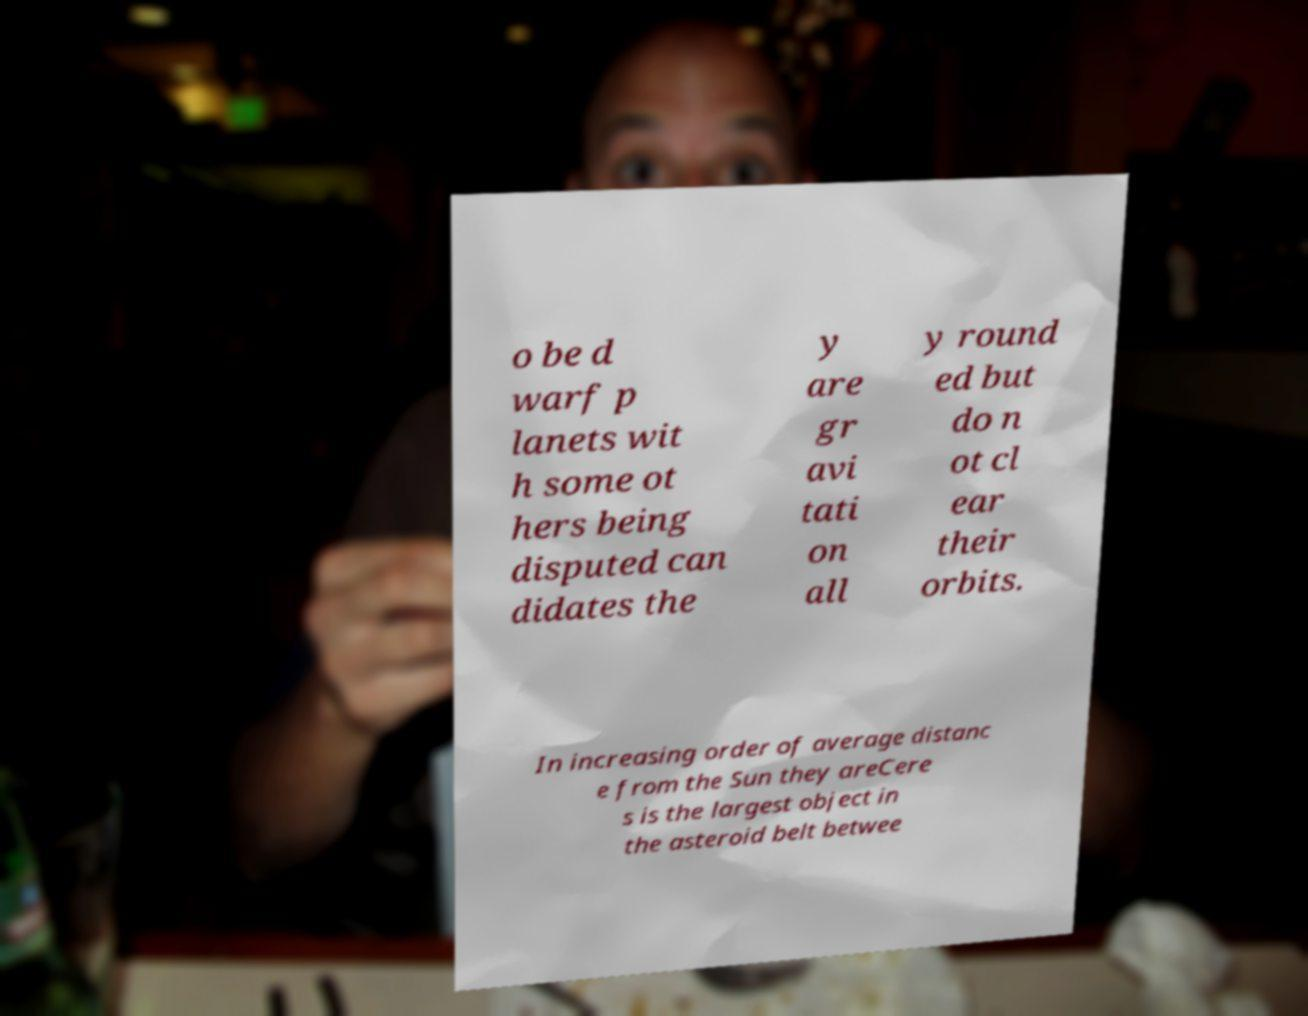Can you accurately transcribe the text from the provided image for me? o be d warf p lanets wit h some ot hers being disputed can didates the y are gr avi tati on all y round ed but do n ot cl ear their orbits. In increasing order of average distanc e from the Sun they areCere s is the largest object in the asteroid belt betwee 